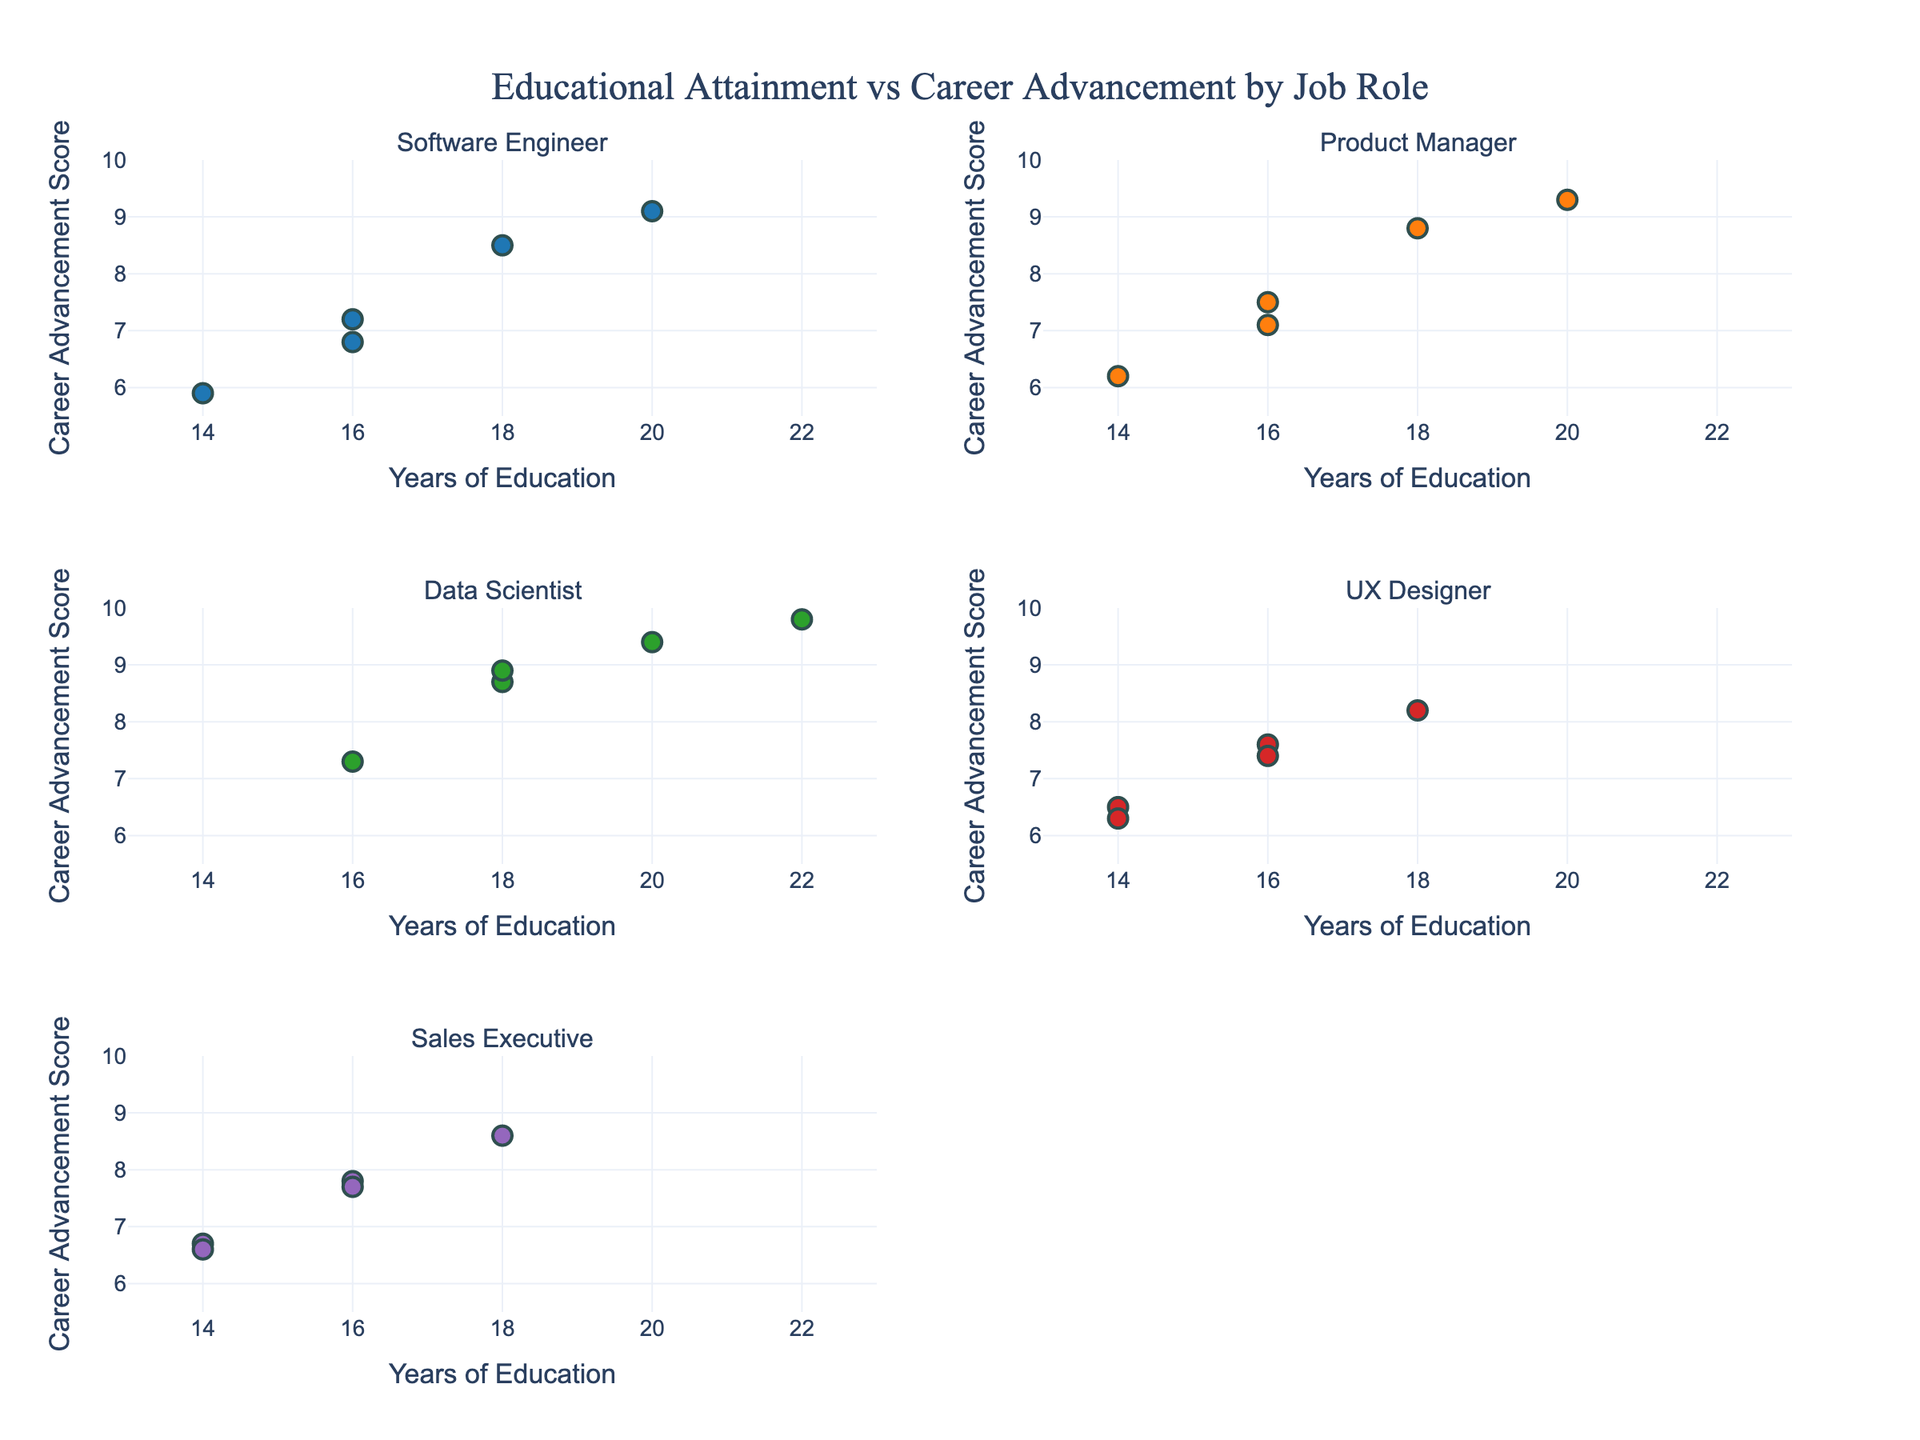What's the title of the figure? The title is typically located at the top center of the figure. In this case, it reads "Educational Attainment vs Career Advancement by Job Role".
Answer: Educational Attainment vs Career Advancement by Job Role What are the axis labels for each subplot? Both the x- and y-axes for each subplot have the same labels. The x-axis is labeled "Years of Education", and the y-axis is labeled "Career Advancement Score".
Answer: Years of Education; Career Advancement Score How does the advancement score vary with years of education for Software Engineers? By looking at the scatter plot for Software Engineers, we can observe a trend where the Career Advancement Score generally increases with Years of Education.
Answer: Higher education generally results in higher career advancement Which job role has the highest career advancement score with 20 years of education? Looking at each subplot, the Data Scientist role has a data point with the highest career advancement score of 9.4 for 20 years of education.
Answer: Data Scientist How many data points are plotted for UX Designers and what range do they cover for years of education? UX Designers have 5 data points ranging from 14 to 18 years of education based on their respective subplot.
Answer: 5; 14 to 18 years Is there a job role where 16 years of education leads to the highest career advancement score compared to other roles with the same education level? By comparing the scatter plots across all job roles at the 16-year mark, Data Scientists appear to have the highest career advancement score at 7.3.
Answer: Data Scientist Which job role shows the least variance in career advancement scores? By examining the scatter plot spread of the career advancement scores, it appears that Sales Executives have a relatively tight grouping, indicating lower variance.
Answer: Sales Executive Which job role has a career advancement score below 6.0 and how many cases are there? The Software Engineer role has one data point with a career advancement score below 6.0 (5.9), visible in their subplot.
Answer: Software Engineer; 1 If you were to average the Career Advancement Scores for Product Managers, what would be the result? Calculate the average by summing the Career Advancement Scores of Product Managers (7.5, 8.8, 9.3, 6.2, 7.1 = 38.9) and dividing by the number of points (5). 38.9 / 5 = 7.78.
Answer: 7.78 